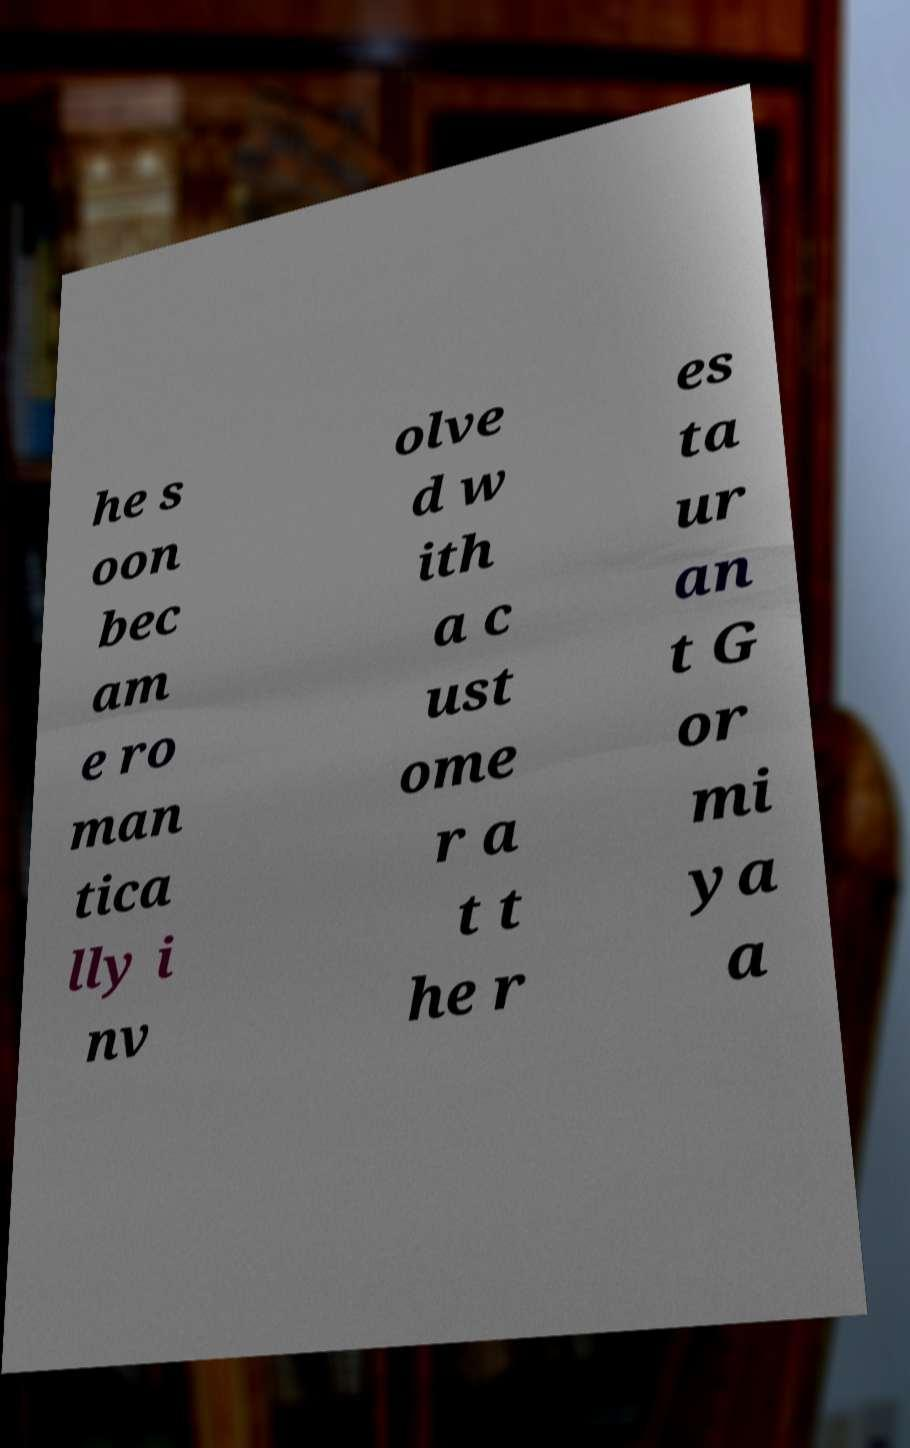Can you accurately transcribe the text from the provided image for me? he s oon bec am e ro man tica lly i nv olve d w ith a c ust ome r a t t he r es ta ur an t G or mi ya a 